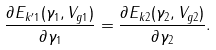Convert formula to latex. <formula><loc_0><loc_0><loc_500><loc_500>\frac { \partial E _ { k ^ { \prime } 1 } ( \gamma _ { 1 } , V _ { g 1 } ) } { \partial \gamma _ { 1 } } = \frac { \partial E _ { k 2 } ( \gamma _ { 2 } , V _ { g 2 } ) } { \partial \gamma _ { 2 } } .</formula> 